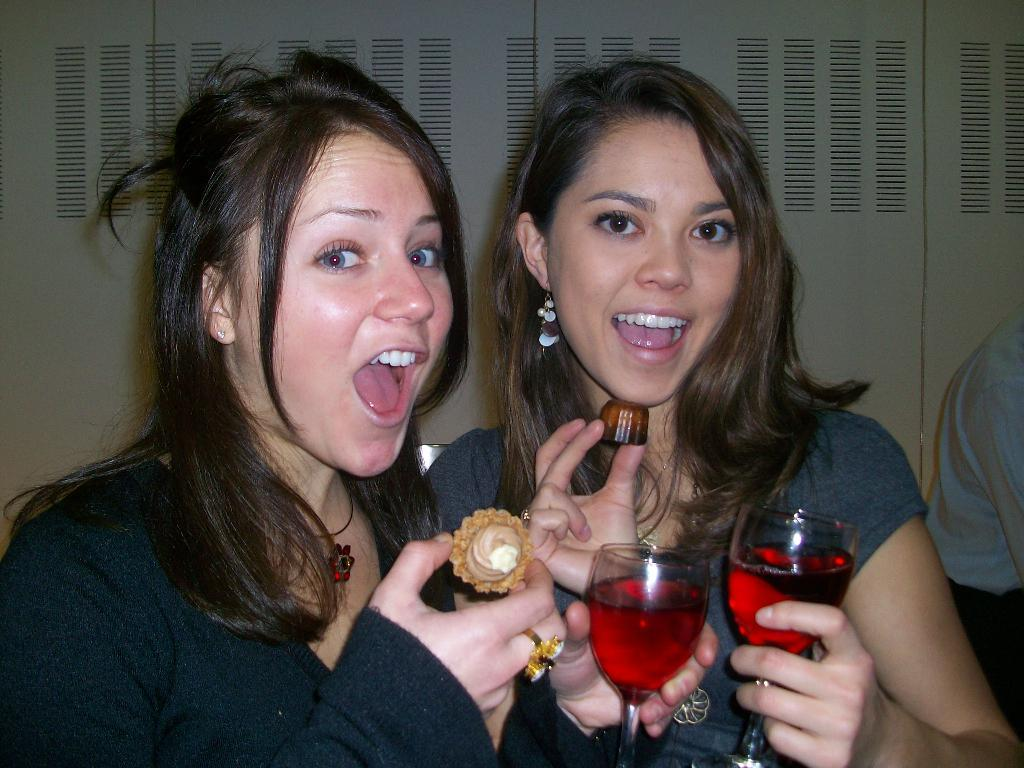How many people are in the image? There are two women in the image. What are the women doing in the image? The women are standing together. What object are the women holding in the image? They are holding a glass. What is inside the glass that the women are holding? The glass contains a liquid. What type of plant can be seen growing in the glass that the women are holding? There is no plant visible in the glass; it contains a liquid. 